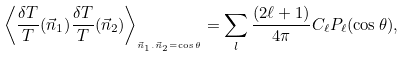<formula> <loc_0><loc_0><loc_500><loc_500>\left < \frac { \delta T } { T } ( \vec { n } _ { 1 } ) \frac { \delta T } { T } ( \vec { n } _ { 2 } ) \right > _ { _ { \vec { n } _ { 1 } . \vec { n } _ { 2 } = \cos { \theta } } } = \sum _ { l } \frac { ( 2 \ell + 1 ) } { 4 \pi } C _ { \ell } P _ { \ell } ( \cos { \theta } ) ,</formula> 